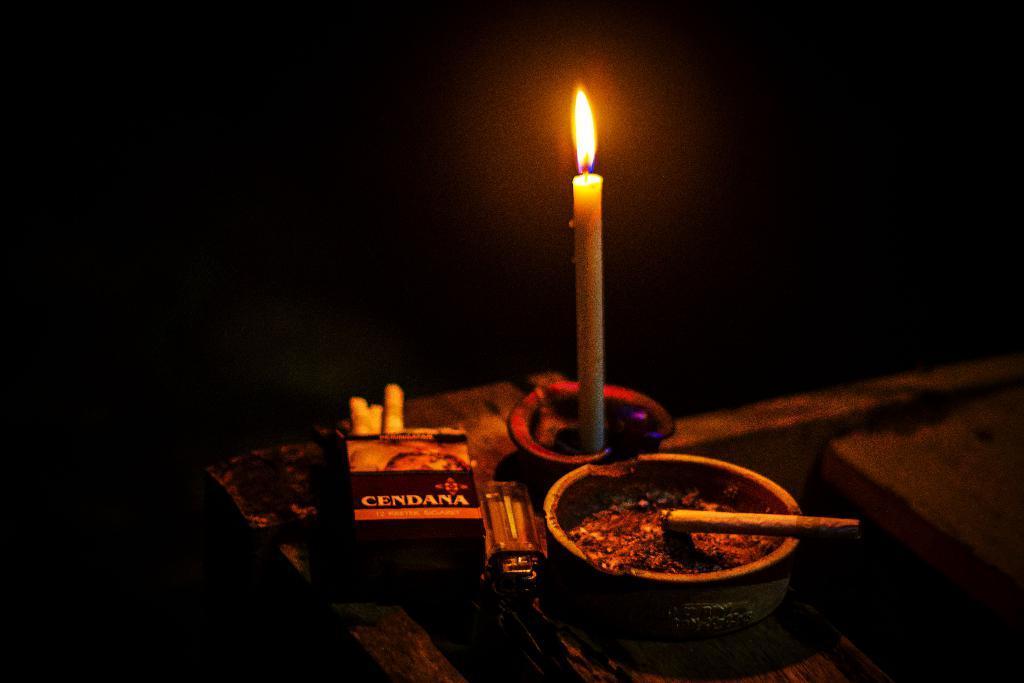Describe this image in one or two sentences. This image consists of a candle kept on a table. There are also cigarettes, lighter and a ashtray on the table. The background is too dark. 